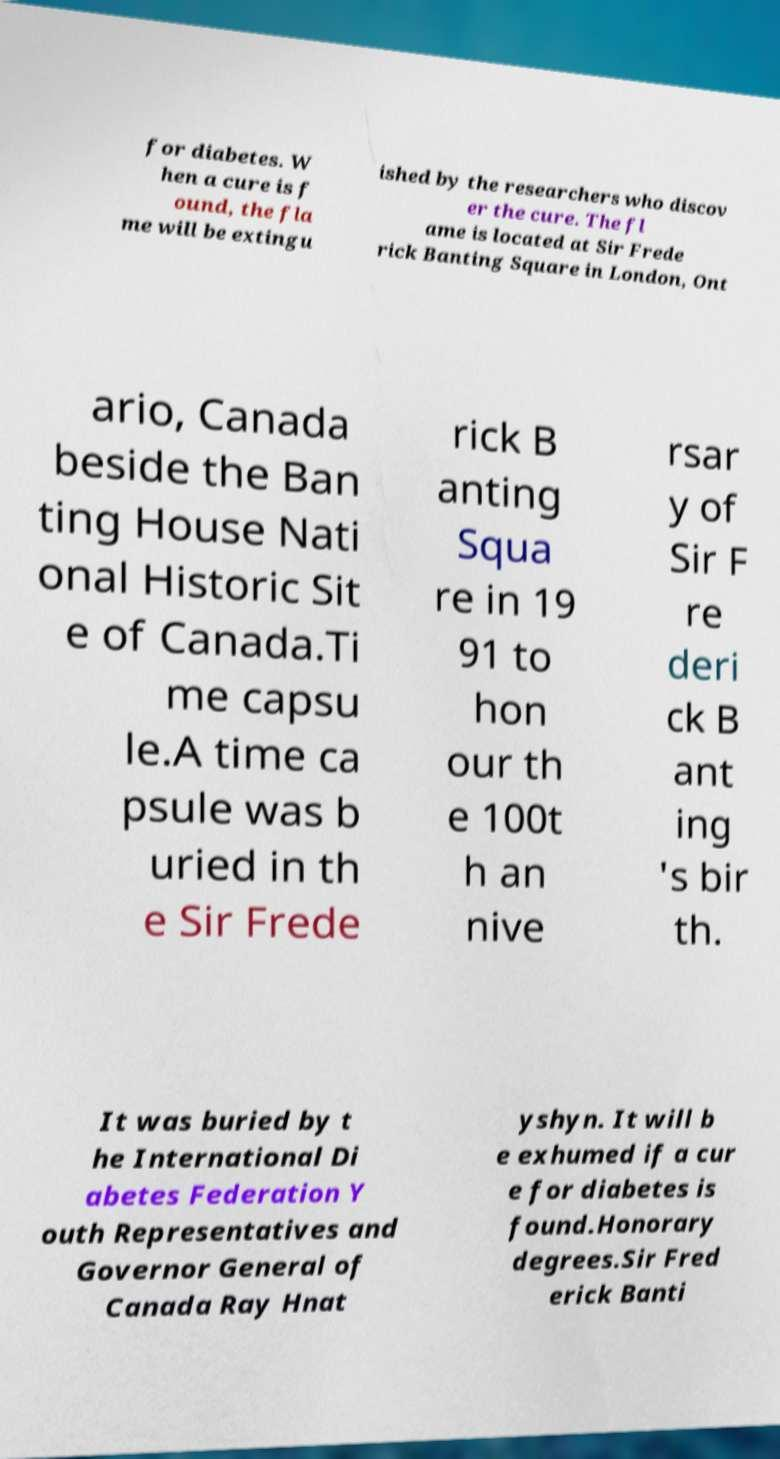Can you read and provide the text displayed in the image?This photo seems to have some interesting text. Can you extract and type it out for me? for diabetes. W hen a cure is f ound, the fla me will be extingu ished by the researchers who discov er the cure. The fl ame is located at Sir Frede rick Banting Square in London, Ont ario, Canada beside the Ban ting House Nati onal Historic Sit e of Canada.Ti me capsu le.A time ca psule was b uried in th e Sir Frede rick B anting Squa re in 19 91 to hon our th e 100t h an nive rsar y of Sir F re deri ck B ant ing 's bir th. It was buried by t he International Di abetes Federation Y outh Representatives and Governor General of Canada Ray Hnat yshyn. It will b e exhumed if a cur e for diabetes is found.Honorary degrees.Sir Fred erick Banti 